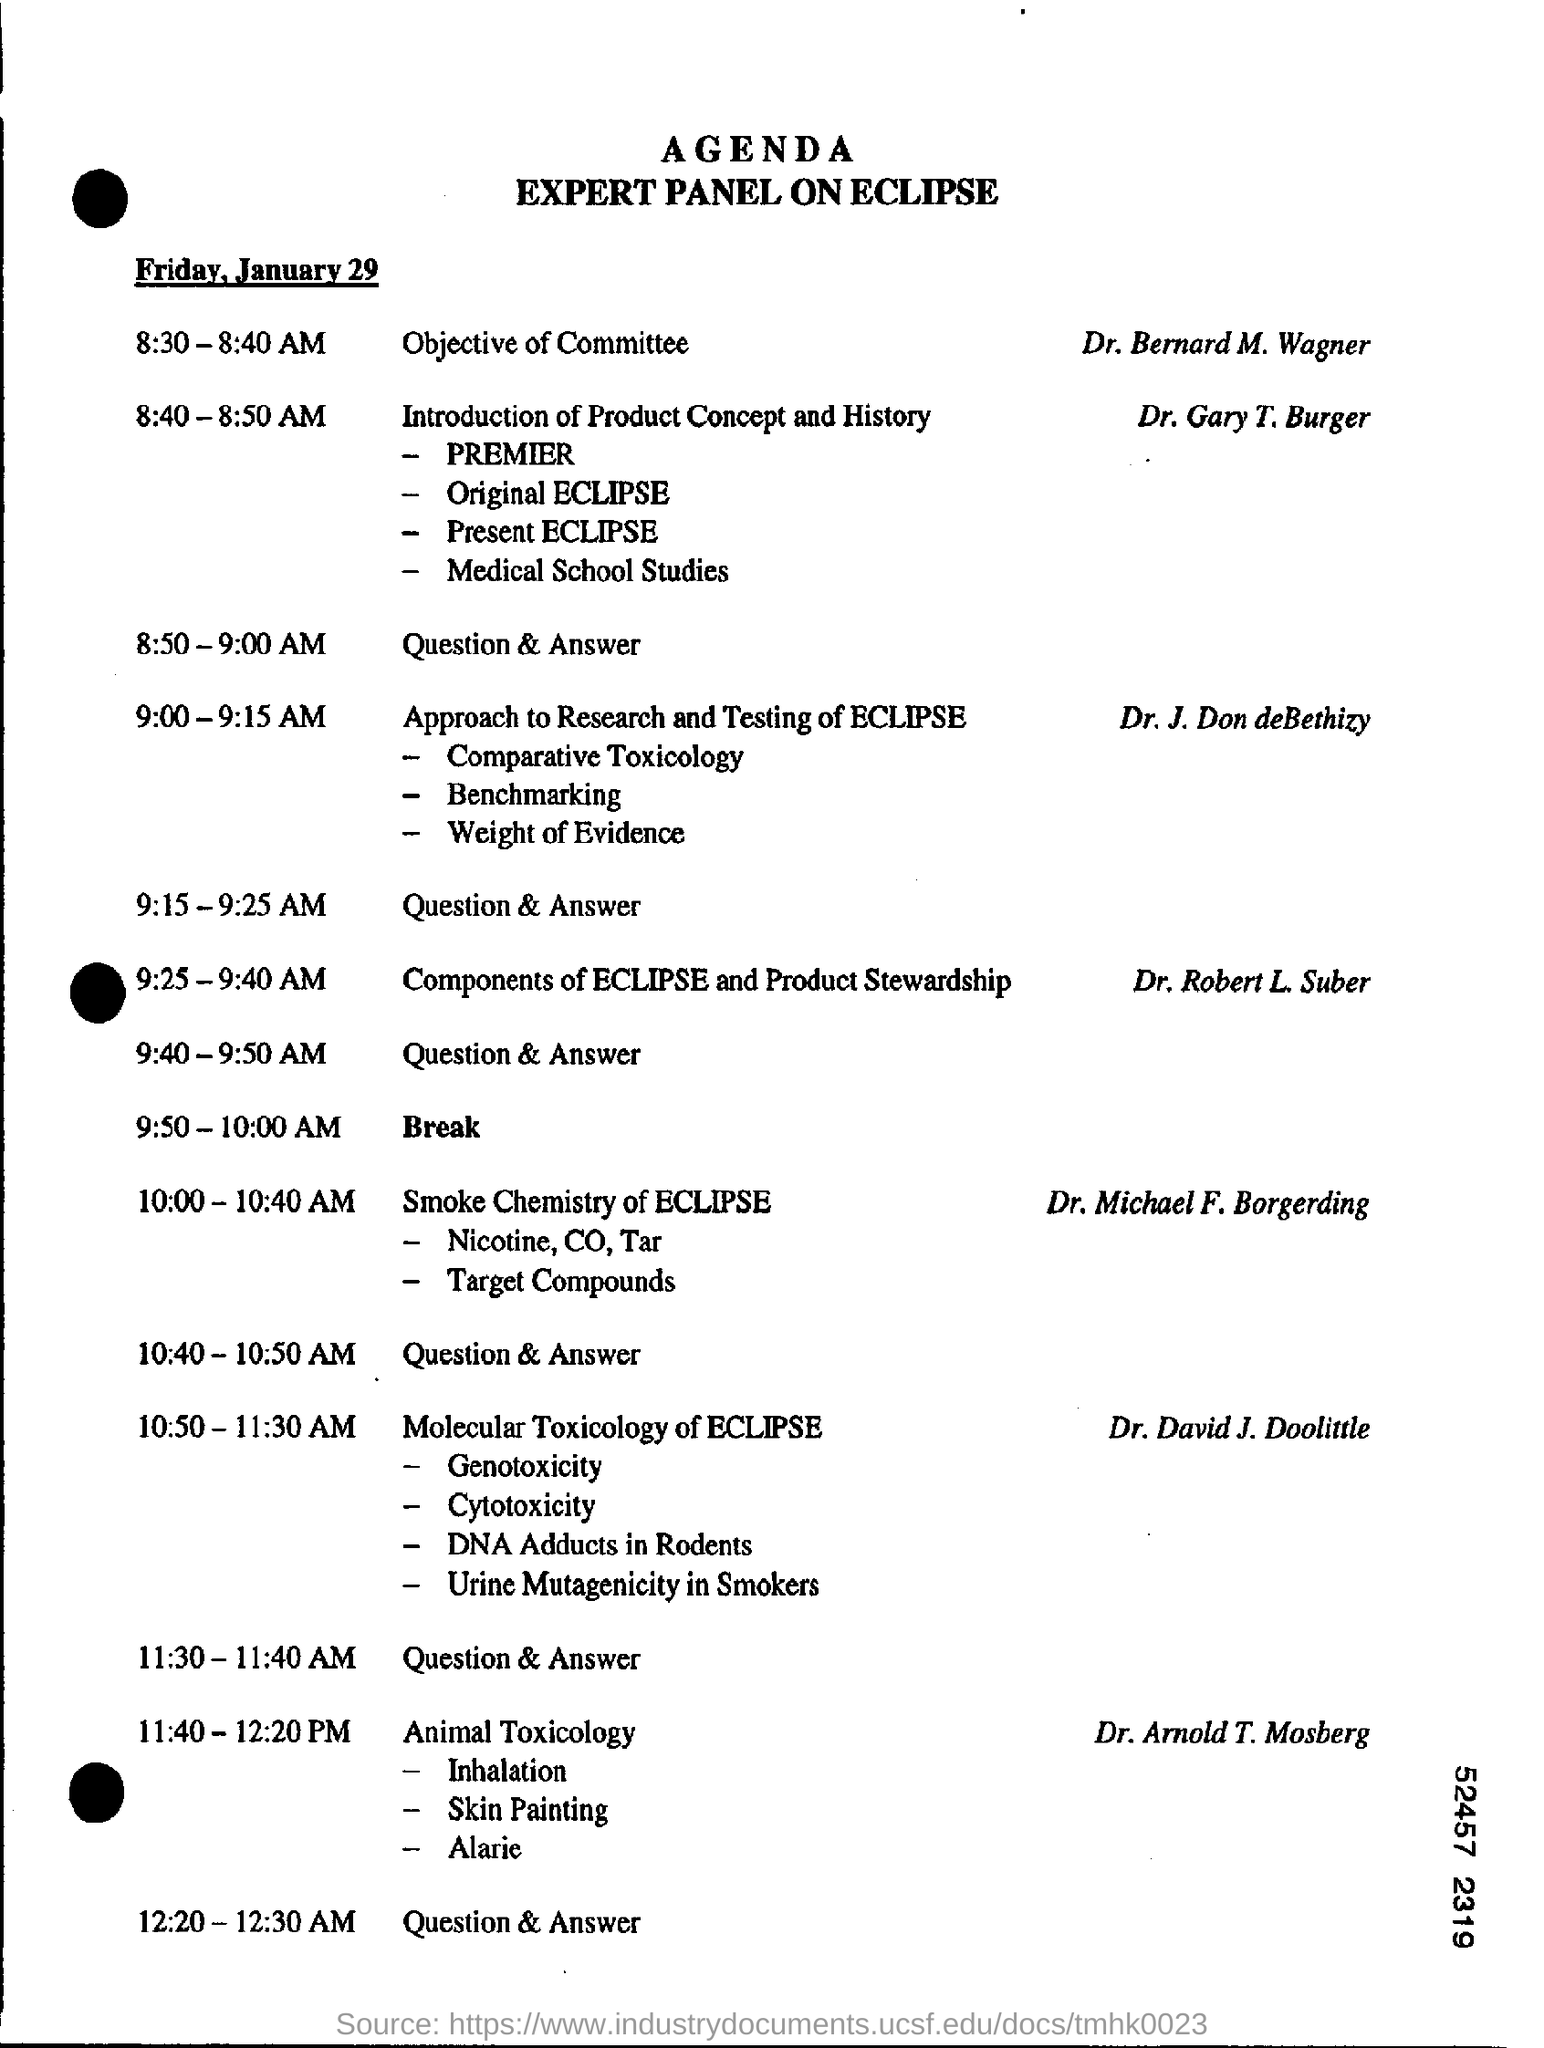What day of the week is january 29?
Your answer should be compact. Friday. Who is speaking on animal toxicology ?
Your response must be concise. Dr. Arnold T. Mosberg. Who gave introduction of product concept and history ?
Your answer should be very brief. Dr. Gary T. Burger. When is the break scheduled ?
Provide a short and direct response. 9:50 - 10:00 AM. 